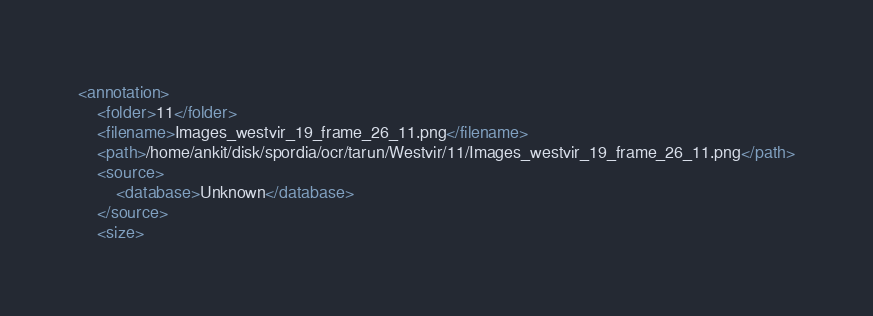Convert code to text. <code><loc_0><loc_0><loc_500><loc_500><_XML_><annotation>
	<folder>11</folder>
	<filename>Images_westvir_19_frame_26_11.png</filename>
	<path>/home/ankit/disk/spordia/ocr/tarun/Westvir/11/Images_westvir_19_frame_26_11.png</path>
	<source>
		<database>Unknown</database>
	</source>
	<size></code> 